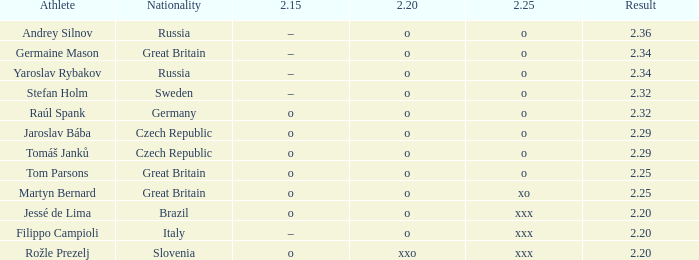What is the 2.15 for Tom Parsons? O. 